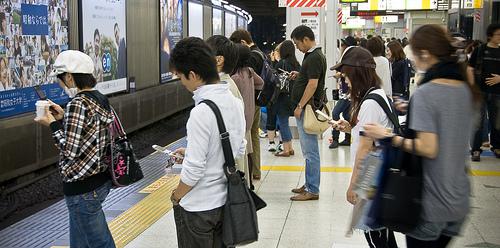Which direction is the red arrow pointing?
Give a very brief answer. Right. What does the woman in front have on her chin?
Answer briefly. Mask. Is everyone on a cell phone?
Be succinct. Yes. 